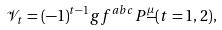Convert formula to latex. <formula><loc_0><loc_0><loc_500><loc_500>\mathcal { V } _ { t } = ( - 1 ) ^ { t - 1 } g f ^ { a b c } P ^ { \underline { \mu } } ( t = 1 , 2 ) ,</formula> 